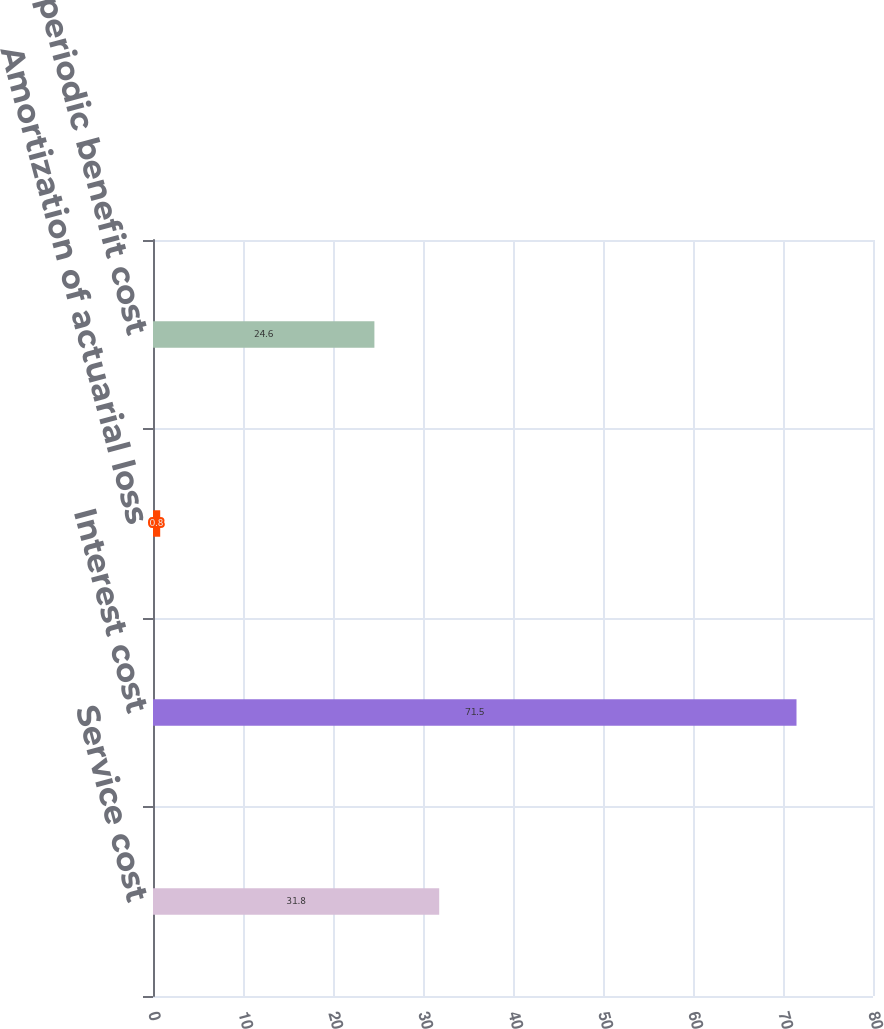Convert chart. <chart><loc_0><loc_0><loc_500><loc_500><bar_chart><fcel>Service cost<fcel>Interest cost<fcel>Amortization of actuarial loss<fcel>Net periodic benefit cost<nl><fcel>31.8<fcel>71.5<fcel>0.8<fcel>24.6<nl></chart> 